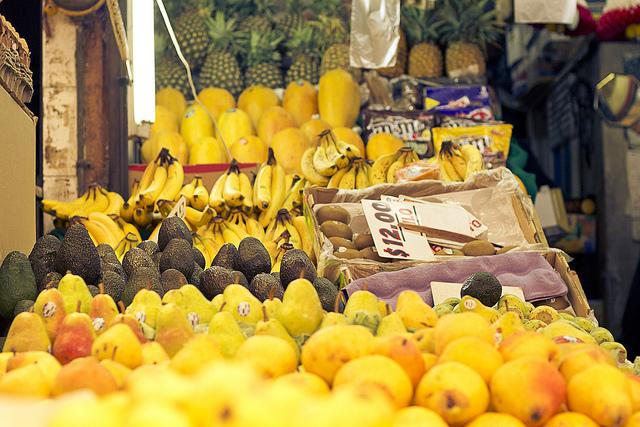What are these yellow fruit?
Quick response, please. Pears. What is the yellow produce?
Give a very brief answer. Bananas. What kind of candy is in this picture?
Answer briefly. M&m's. Are the bananas green?
Keep it brief. No. What kind of fruit is pictured?
Keep it brief. Pears, avocados, bananas. What is the most prominent color in the picture?
Write a very short answer. Yellow. Is there a pear in this picture?
Give a very brief answer. Yes. 